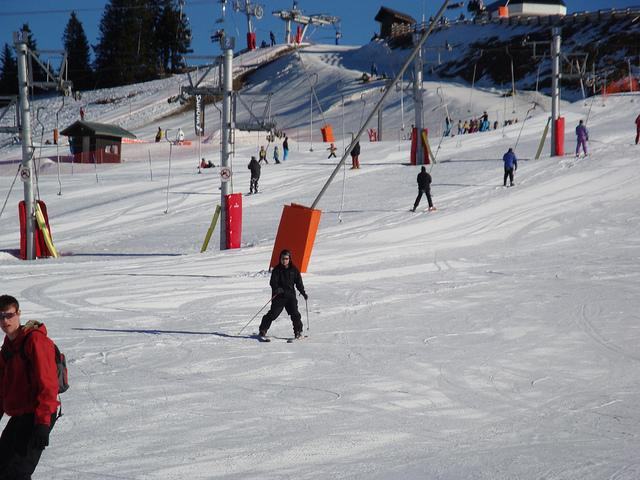What is the man dressed in all black and in the middle of the scene holding? Please explain your reasoning. ski poles. The man is participating in a winter sport. he is not holding a living thing. 